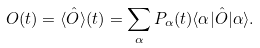<formula> <loc_0><loc_0><loc_500><loc_500>O ( t ) = \langle \hat { O } \rangle ( t ) = \sum _ { \alpha } P _ { \alpha } ( t ) \langle \alpha | \hat { O } | \alpha \rangle .</formula> 